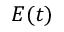<formula> <loc_0><loc_0><loc_500><loc_500>E ( t )</formula> 